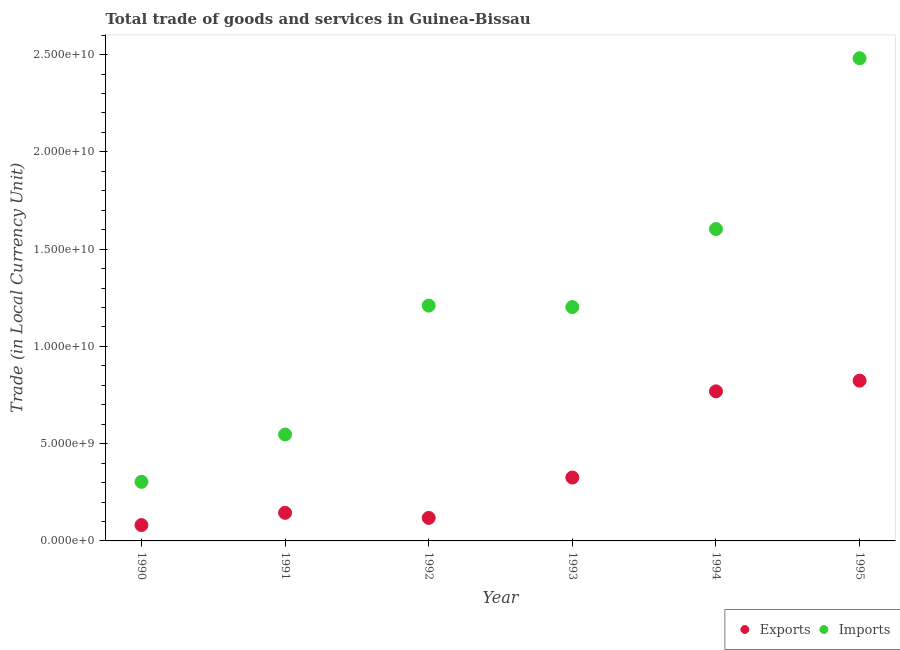How many different coloured dotlines are there?
Ensure brevity in your answer.  2. What is the imports of goods and services in 1994?
Provide a succinct answer. 1.60e+1. Across all years, what is the maximum imports of goods and services?
Your answer should be compact. 2.48e+1. Across all years, what is the minimum imports of goods and services?
Offer a terse response. 3.04e+09. In which year was the imports of goods and services minimum?
Keep it short and to the point. 1990. What is the total export of goods and services in the graph?
Keep it short and to the point. 2.26e+1. What is the difference between the export of goods and services in 1994 and that in 1995?
Keep it short and to the point. -5.49e+08. What is the difference between the export of goods and services in 1990 and the imports of goods and services in 1992?
Your answer should be very brief. -1.13e+1. What is the average imports of goods and services per year?
Your answer should be very brief. 1.22e+1. In the year 1991, what is the difference between the export of goods and services and imports of goods and services?
Keep it short and to the point. -4.03e+09. What is the ratio of the imports of goods and services in 1991 to that in 1992?
Keep it short and to the point. 0.45. Is the export of goods and services in 1990 less than that in 1994?
Your response must be concise. Yes. What is the difference between the highest and the second highest imports of goods and services?
Your answer should be very brief. 8.78e+09. What is the difference between the highest and the lowest export of goods and services?
Provide a succinct answer. 7.42e+09. Does the export of goods and services monotonically increase over the years?
Your answer should be very brief. No. How many dotlines are there?
Ensure brevity in your answer.  2. How many years are there in the graph?
Your response must be concise. 6. Does the graph contain grids?
Keep it short and to the point. No. How many legend labels are there?
Give a very brief answer. 2. How are the legend labels stacked?
Give a very brief answer. Horizontal. What is the title of the graph?
Offer a terse response. Total trade of goods and services in Guinea-Bissau. What is the label or title of the X-axis?
Your answer should be compact. Year. What is the label or title of the Y-axis?
Provide a short and direct response. Trade (in Local Currency Unit). What is the Trade (in Local Currency Unit) of Exports in 1990?
Ensure brevity in your answer.  8.15e+08. What is the Trade (in Local Currency Unit) of Imports in 1990?
Keep it short and to the point. 3.04e+09. What is the Trade (in Local Currency Unit) in Exports in 1991?
Offer a terse response. 1.44e+09. What is the Trade (in Local Currency Unit) of Imports in 1991?
Give a very brief answer. 5.47e+09. What is the Trade (in Local Currency Unit) in Exports in 1992?
Give a very brief answer. 1.18e+09. What is the Trade (in Local Currency Unit) in Imports in 1992?
Your answer should be compact. 1.21e+1. What is the Trade (in Local Currency Unit) of Exports in 1993?
Provide a succinct answer. 3.26e+09. What is the Trade (in Local Currency Unit) in Imports in 1993?
Offer a very short reply. 1.20e+1. What is the Trade (in Local Currency Unit) of Exports in 1994?
Offer a very short reply. 7.69e+09. What is the Trade (in Local Currency Unit) of Imports in 1994?
Your response must be concise. 1.60e+1. What is the Trade (in Local Currency Unit) of Exports in 1995?
Keep it short and to the point. 8.24e+09. What is the Trade (in Local Currency Unit) of Imports in 1995?
Provide a succinct answer. 2.48e+1. Across all years, what is the maximum Trade (in Local Currency Unit) in Exports?
Provide a short and direct response. 8.24e+09. Across all years, what is the maximum Trade (in Local Currency Unit) in Imports?
Your response must be concise. 2.48e+1. Across all years, what is the minimum Trade (in Local Currency Unit) in Exports?
Make the answer very short. 8.15e+08. Across all years, what is the minimum Trade (in Local Currency Unit) of Imports?
Offer a terse response. 3.04e+09. What is the total Trade (in Local Currency Unit) in Exports in the graph?
Offer a terse response. 2.26e+1. What is the total Trade (in Local Currency Unit) in Imports in the graph?
Keep it short and to the point. 7.35e+1. What is the difference between the Trade (in Local Currency Unit) of Exports in 1990 and that in 1991?
Your response must be concise. -6.30e+08. What is the difference between the Trade (in Local Currency Unit) in Imports in 1990 and that in 1991?
Ensure brevity in your answer.  -2.43e+09. What is the difference between the Trade (in Local Currency Unit) of Exports in 1990 and that in 1992?
Offer a very short reply. -3.69e+08. What is the difference between the Trade (in Local Currency Unit) in Imports in 1990 and that in 1992?
Your answer should be very brief. -9.06e+09. What is the difference between the Trade (in Local Currency Unit) in Exports in 1990 and that in 1993?
Provide a succinct answer. -2.44e+09. What is the difference between the Trade (in Local Currency Unit) of Imports in 1990 and that in 1993?
Your answer should be compact. -8.98e+09. What is the difference between the Trade (in Local Currency Unit) of Exports in 1990 and that in 1994?
Give a very brief answer. -6.87e+09. What is the difference between the Trade (in Local Currency Unit) of Imports in 1990 and that in 1994?
Offer a terse response. -1.30e+1. What is the difference between the Trade (in Local Currency Unit) of Exports in 1990 and that in 1995?
Your response must be concise. -7.42e+09. What is the difference between the Trade (in Local Currency Unit) in Imports in 1990 and that in 1995?
Give a very brief answer. -2.18e+1. What is the difference between the Trade (in Local Currency Unit) of Exports in 1991 and that in 1992?
Give a very brief answer. 2.61e+08. What is the difference between the Trade (in Local Currency Unit) in Imports in 1991 and that in 1992?
Give a very brief answer. -6.63e+09. What is the difference between the Trade (in Local Currency Unit) in Exports in 1991 and that in 1993?
Provide a short and direct response. -1.81e+09. What is the difference between the Trade (in Local Currency Unit) in Imports in 1991 and that in 1993?
Keep it short and to the point. -6.55e+09. What is the difference between the Trade (in Local Currency Unit) in Exports in 1991 and that in 1994?
Your answer should be very brief. -6.24e+09. What is the difference between the Trade (in Local Currency Unit) in Imports in 1991 and that in 1994?
Give a very brief answer. -1.06e+1. What is the difference between the Trade (in Local Currency Unit) of Exports in 1991 and that in 1995?
Your answer should be compact. -6.79e+09. What is the difference between the Trade (in Local Currency Unit) in Imports in 1991 and that in 1995?
Give a very brief answer. -1.93e+1. What is the difference between the Trade (in Local Currency Unit) in Exports in 1992 and that in 1993?
Make the answer very short. -2.08e+09. What is the difference between the Trade (in Local Currency Unit) in Imports in 1992 and that in 1993?
Your response must be concise. 7.73e+07. What is the difference between the Trade (in Local Currency Unit) in Exports in 1992 and that in 1994?
Provide a short and direct response. -6.51e+09. What is the difference between the Trade (in Local Currency Unit) in Imports in 1992 and that in 1994?
Your answer should be very brief. -3.94e+09. What is the difference between the Trade (in Local Currency Unit) of Exports in 1992 and that in 1995?
Make the answer very short. -7.05e+09. What is the difference between the Trade (in Local Currency Unit) in Imports in 1992 and that in 1995?
Offer a terse response. -1.27e+1. What is the difference between the Trade (in Local Currency Unit) in Exports in 1993 and that in 1994?
Make the answer very short. -4.43e+09. What is the difference between the Trade (in Local Currency Unit) in Imports in 1993 and that in 1994?
Your answer should be very brief. -4.01e+09. What is the difference between the Trade (in Local Currency Unit) in Exports in 1993 and that in 1995?
Keep it short and to the point. -4.98e+09. What is the difference between the Trade (in Local Currency Unit) in Imports in 1993 and that in 1995?
Your answer should be very brief. -1.28e+1. What is the difference between the Trade (in Local Currency Unit) in Exports in 1994 and that in 1995?
Your response must be concise. -5.49e+08. What is the difference between the Trade (in Local Currency Unit) in Imports in 1994 and that in 1995?
Keep it short and to the point. -8.78e+09. What is the difference between the Trade (in Local Currency Unit) of Exports in 1990 and the Trade (in Local Currency Unit) of Imports in 1991?
Keep it short and to the point. -4.65e+09. What is the difference between the Trade (in Local Currency Unit) in Exports in 1990 and the Trade (in Local Currency Unit) in Imports in 1992?
Your answer should be very brief. -1.13e+1. What is the difference between the Trade (in Local Currency Unit) of Exports in 1990 and the Trade (in Local Currency Unit) of Imports in 1993?
Offer a terse response. -1.12e+1. What is the difference between the Trade (in Local Currency Unit) in Exports in 1990 and the Trade (in Local Currency Unit) in Imports in 1994?
Offer a very short reply. -1.52e+1. What is the difference between the Trade (in Local Currency Unit) in Exports in 1990 and the Trade (in Local Currency Unit) in Imports in 1995?
Offer a very short reply. -2.40e+1. What is the difference between the Trade (in Local Currency Unit) in Exports in 1991 and the Trade (in Local Currency Unit) in Imports in 1992?
Your response must be concise. -1.07e+1. What is the difference between the Trade (in Local Currency Unit) in Exports in 1991 and the Trade (in Local Currency Unit) in Imports in 1993?
Make the answer very short. -1.06e+1. What is the difference between the Trade (in Local Currency Unit) of Exports in 1991 and the Trade (in Local Currency Unit) of Imports in 1994?
Provide a succinct answer. -1.46e+1. What is the difference between the Trade (in Local Currency Unit) of Exports in 1991 and the Trade (in Local Currency Unit) of Imports in 1995?
Ensure brevity in your answer.  -2.34e+1. What is the difference between the Trade (in Local Currency Unit) of Exports in 1992 and the Trade (in Local Currency Unit) of Imports in 1993?
Your answer should be compact. -1.08e+1. What is the difference between the Trade (in Local Currency Unit) of Exports in 1992 and the Trade (in Local Currency Unit) of Imports in 1994?
Ensure brevity in your answer.  -1.49e+1. What is the difference between the Trade (in Local Currency Unit) in Exports in 1992 and the Trade (in Local Currency Unit) in Imports in 1995?
Ensure brevity in your answer.  -2.36e+1. What is the difference between the Trade (in Local Currency Unit) of Exports in 1993 and the Trade (in Local Currency Unit) of Imports in 1994?
Provide a succinct answer. -1.28e+1. What is the difference between the Trade (in Local Currency Unit) in Exports in 1993 and the Trade (in Local Currency Unit) in Imports in 1995?
Give a very brief answer. -2.16e+1. What is the difference between the Trade (in Local Currency Unit) of Exports in 1994 and the Trade (in Local Currency Unit) of Imports in 1995?
Your answer should be very brief. -1.71e+1. What is the average Trade (in Local Currency Unit) of Exports per year?
Make the answer very short. 3.77e+09. What is the average Trade (in Local Currency Unit) in Imports per year?
Offer a terse response. 1.22e+1. In the year 1990, what is the difference between the Trade (in Local Currency Unit) of Exports and Trade (in Local Currency Unit) of Imports?
Offer a terse response. -2.22e+09. In the year 1991, what is the difference between the Trade (in Local Currency Unit) in Exports and Trade (in Local Currency Unit) in Imports?
Keep it short and to the point. -4.03e+09. In the year 1992, what is the difference between the Trade (in Local Currency Unit) of Exports and Trade (in Local Currency Unit) of Imports?
Make the answer very short. -1.09e+1. In the year 1993, what is the difference between the Trade (in Local Currency Unit) of Exports and Trade (in Local Currency Unit) of Imports?
Offer a terse response. -8.76e+09. In the year 1994, what is the difference between the Trade (in Local Currency Unit) of Exports and Trade (in Local Currency Unit) of Imports?
Your answer should be very brief. -8.34e+09. In the year 1995, what is the difference between the Trade (in Local Currency Unit) in Exports and Trade (in Local Currency Unit) in Imports?
Give a very brief answer. -1.66e+1. What is the ratio of the Trade (in Local Currency Unit) of Exports in 1990 to that in 1991?
Offer a very short reply. 0.56. What is the ratio of the Trade (in Local Currency Unit) of Imports in 1990 to that in 1991?
Ensure brevity in your answer.  0.56. What is the ratio of the Trade (in Local Currency Unit) of Exports in 1990 to that in 1992?
Provide a succinct answer. 0.69. What is the ratio of the Trade (in Local Currency Unit) in Imports in 1990 to that in 1992?
Your answer should be very brief. 0.25. What is the ratio of the Trade (in Local Currency Unit) in Exports in 1990 to that in 1993?
Your response must be concise. 0.25. What is the ratio of the Trade (in Local Currency Unit) of Imports in 1990 to that in 1993?
Offer a very short reply. 0.25. What is the ratio of the Trade (in Local Currency Unit) in Exports in 1990 to that in 1994?
Provide a succinct answer. 0.11. What is the ratio of the Trade (in Local Currency Unit) of Imports in 1990 to that in 1994?
Ensure brevity in your answer.  0.19. What is the ratio of the Trade (in Local Currency Unit) of Exports in 1990 to that in 1995?
Offer a terse response. 0.1. What is the ratio of the Trade (in Local Currency Unit) in Imports in 1990 to that in 1995?
Offer a very short reply. 0.12. What is the ratio of the Trade (in Local Currency Unit) of Exports in 1991 to that in 1992?
Offer a terse response. 1.22. What is the ratio of the Trade (in Local Currency Unit) of Imports in 1991 to that in 1992?
Your response must be concise. 0.45. What is the ratio of the Trade (in Local Currency Unit) in Exports in 1991 to that in 1993?
Ensure brevity in your answer.  0.44. What is the ratio of the Trade (in Local Currency Unit) of Imports in 1991 to that in 1993?
Your answer should be very brief. 0.46. What is the ratio of the Trade (in Local Currency Unit) in Exports in 1991 to that in 1994?
Make the answer very short. 0.19. What is the ratio of the Trade (in Local Currency Unit) of Imports in 1991 to that in 1994?
Offer a terse response. 0.34. What is the ratio of the Trade (in Local Currency Unit) in Exports in 1991 to that in 1995?
Provide a short and direct response. 0.18. What is the ratio of the Trade (in Local Currency Unit) of Imports in 1991 to that in 1995?
Your response must be concise. 0.22. What is the ratio of the Trade (in Local Currency Unit) in Exports in 1992 to that in 1993?
Your answer should be compact. 0.36. What is the ratio of the Trade (in Local Currency Unit) in Imports in 1992 to that in 1993?
Your response must be concise. 1.01. What is the ratio of the Trade (in Local Currency Unit) of Exports in 1992 to that in 1994?
Your answer should be compact. 0.15. What is the ratio of the Trade (in Local Currency Unit) in Imports in 1992 to that in 1994?
Your answer should be very brief. 0.75. What is the ratio of the Trade (in Local Currency Unit) in Exports in 1992 to that in 1995?
Ensure brevity in your answer.  0.14. What is the ratio of the Trade (in Local Currency Unit) of Imports in 1992 to that in 1995?
Ensure brevity in your answer.  0.49. What is the ratio of the Trade (in Local Currency Unit) in Exports in 1993 to that in 1994?
Your response must be concise. 0.42. What is the ratio of the Trade (in Local Currency Unit) in Imports in 1993 to that in 1994?
Offer a terse response. 0.75. What is the ratio of the Trade (in Local Currency Unit) of Exports in 1993 to that in 1995?
Provide a short and direct response. 0.4. What is the ratio of the Trade (in Local Currency Unit) in Imports in 1993 to that in 1995?
Ensure brevity in your answer.  0.48. What is the ratio of the Trade (in Local Currency Unit) of Exports in 1994 to that in 1995?
Your answer should be compact. 0.93. What is the ratio of the Trade (in Local Currency Unit) in Imports in 1994 to that in 1995?
Offer a very short reply. 0.65. What is the difference between the highest and the second highest Trade (in Local Currency Unit) of Exports?
Your answer should be compact. 5.49e+08. What is the difference between the highest and the second highest Trade (in Local Currency Unit) of Imports?
Provide a succinct answer. 8.78e+09. What is the difference between the highest and the lowest Trade (in Local Currency Unit) of Exports?
Provide a short and direct response. 7.42e+09. What is the difference between the highest and the lowest Trade (in Local Currency Unit) in Imports?
Ensure brevity in your answer.  2.18e+1. 